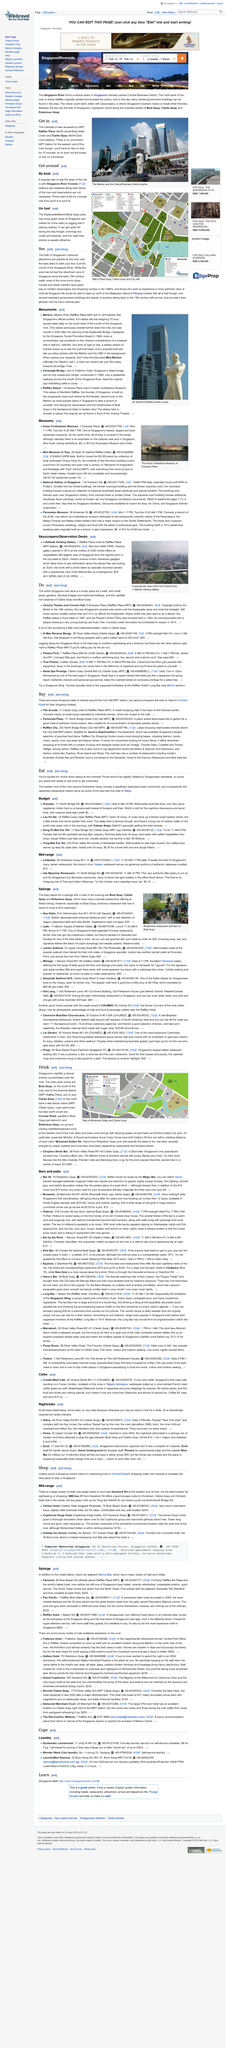Indicate a few pertinent items in this graphic. The Mint Museum of Toys offers a guided tour that typically lasts approximately 45 minutes. Clarke Quay station is located on the North-East line of the North-South line of Singapore's Mass Rapid Transit (MRT) system. The Riverside can be accessed by using the MRT Raffles Place and Clarke Quay stations as mentioned in the article "Get in". The up-and-coming nightlife/restaurant area in Singapore is called Robertson Quay. The collection of the Mint Museum of Toys is comprised of more than 50,000 pieces, making it a vast and impressive assemblage of historical and cultural significance. 